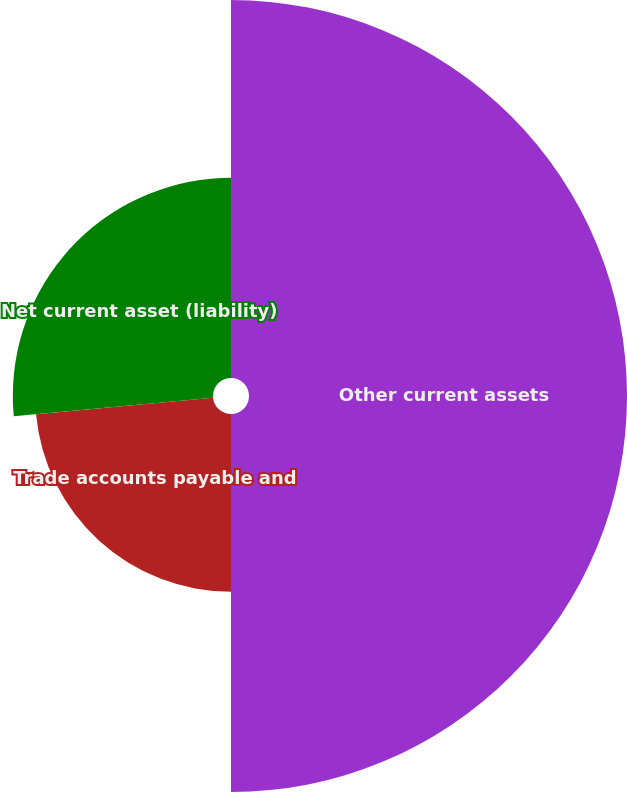Convert chart. <chart><loc_0><loc_0><loc_500><loc_500><pie_chart><fcel>Other current assets<fcel>Trade accounts payable and<fcel>Net current asset (liability)<nl><fcel>50.0%<fcel>23.52%<fcel>26.48%<nl></chart> 